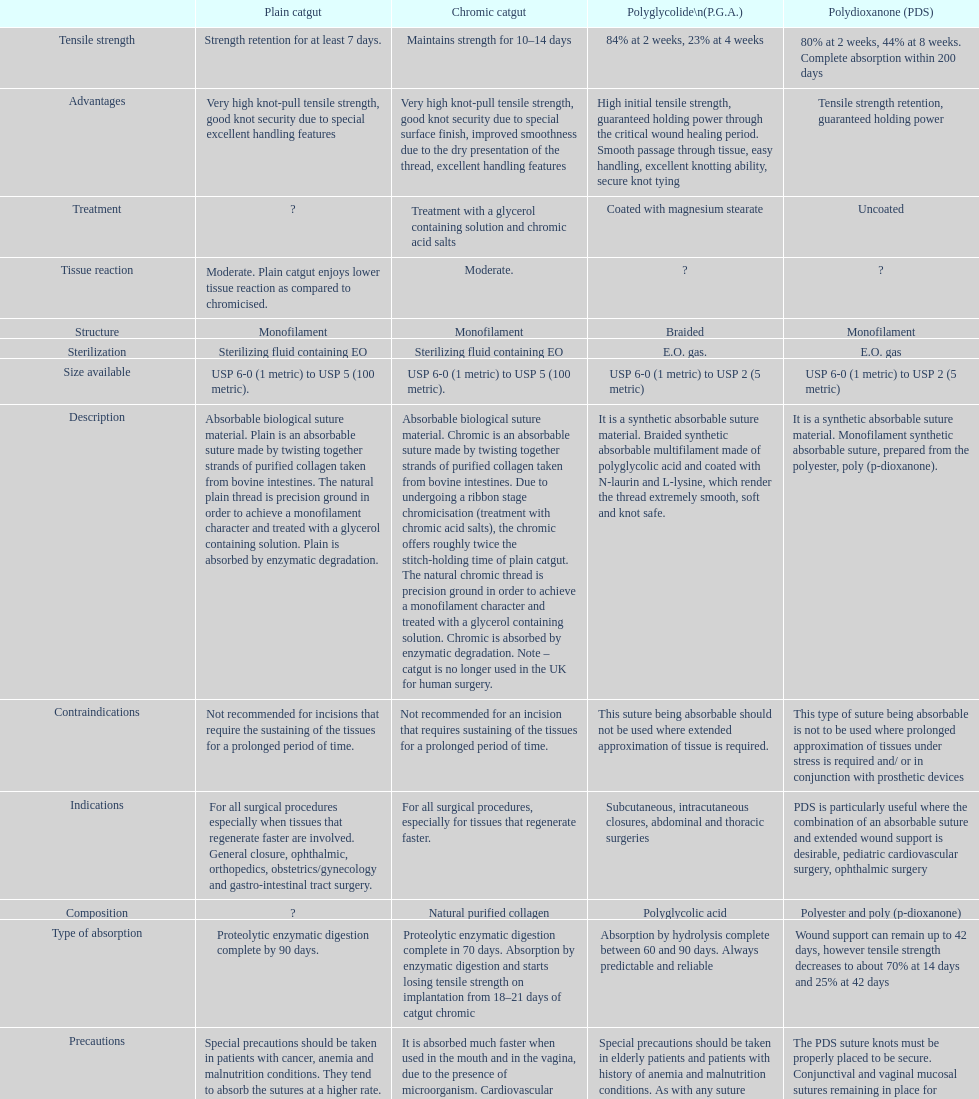What is the total number of suture materials that have a mono-filament structure? 3. 